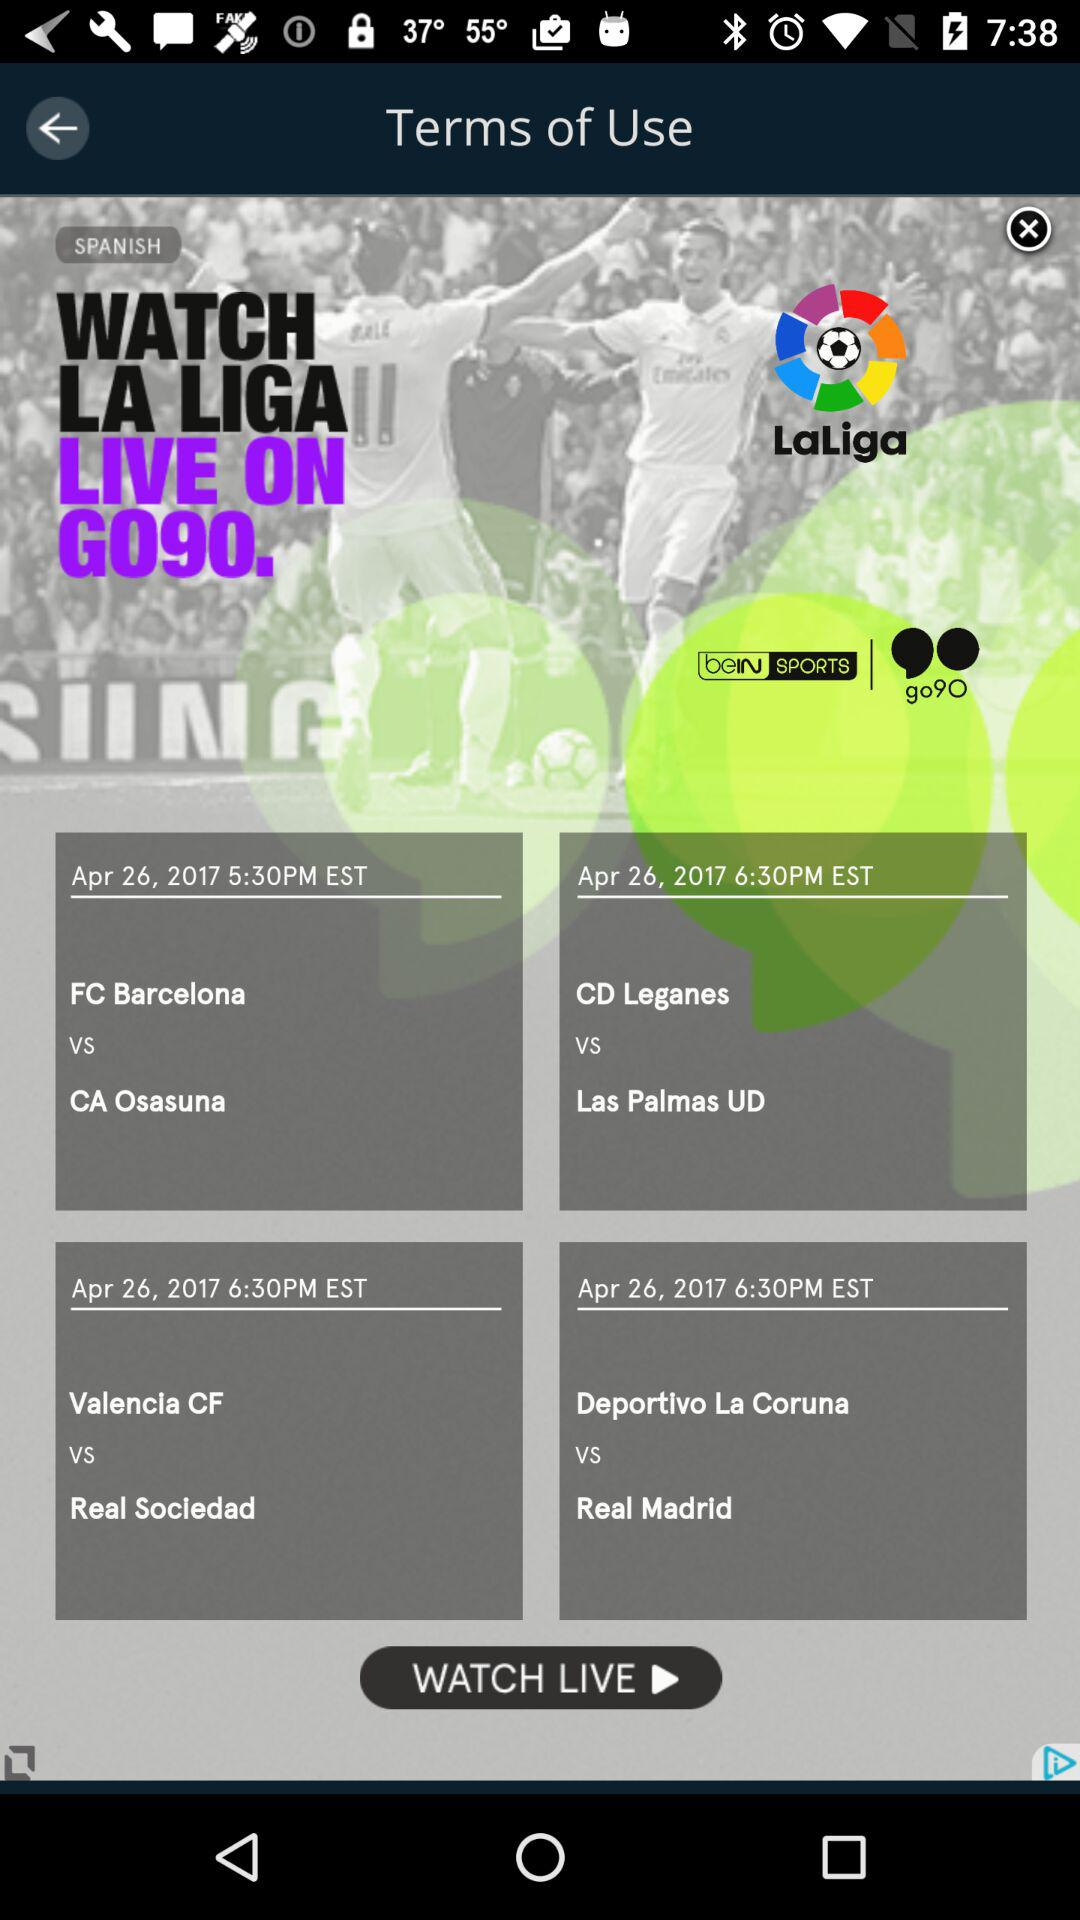How many more teams are playing at 6:30pm than 5:30pm?
Answer the question using a single word or phrase. 2 